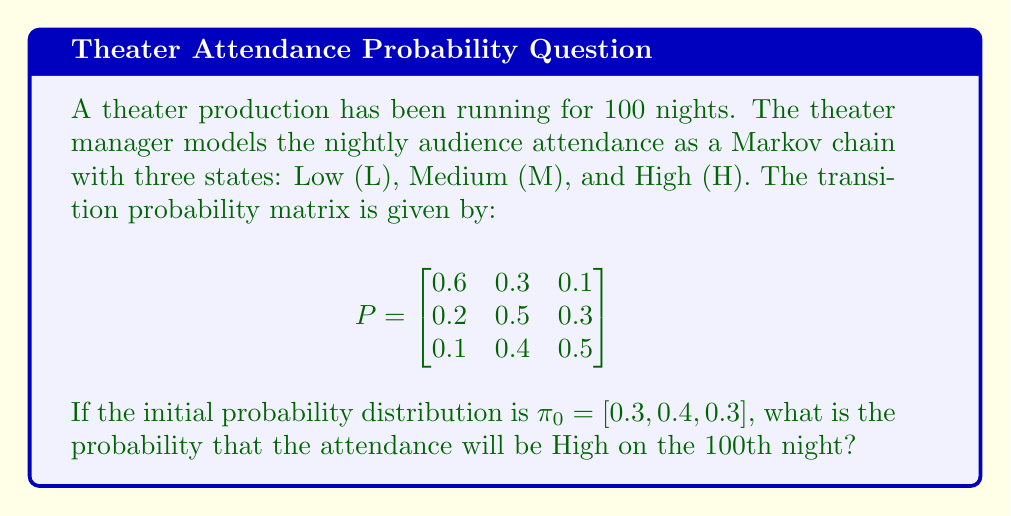Can you answer this question? To solve this problem, we need to find the probability distribution after 100 nights. We can do this by calculating $\pi_{100} = \pi_0 P^{100}$. However, calculating $P^{100}$ directly is computationally intensive. Instead, we can use the fact that for a regular Markov chain, the distribution converges to the stationary distribution as the number of steps increases.

1. First, let's find the stationary distribution $\pi$ by solving the equation $\pi P = \pi$ subject to $\sum_{i} \pi_i = 1$:

   $$\begin{align}
   \pi_1 &= 0.6\pi_1 + 0.2\pi_2 + 0.1\pi_3 \\
   \pi_2 &= 0.3\pi_1 + 0.5\pi_2 + 0.4\pi_3 \\
   \pi_3 &= 0.1\pi_1 + 0.3\pi_2 + 0.5\pi_3 \\
   1 &= \pi_1 + \pi_2 + \pi_3
   \end{align}$$

2. Solving this system of equations (using substitution or matrix methods), we get:
   
   $$\pi = [0.2857, 0.4286, 0.2857]$$

3. Now, we need to check if 100 steps is sufficient for convergence. We can do this by calculating the second largest eigenvalue $\lambda_2$ of $P$:

   $$\lambda_2 \approx 0.3219$$

4. The rate of convergence is governed by $|\lambda_2|^n$, where $n$ is the number of steps. After 100 steps:

   $$|\lambda_2|^{100} \approx (0.3219)^{100} \approx 2.0388 \times 10^{-17}$$

5. This is extremely close to zero, indicating that after 100 steps, the distribution has essentially converged to the stationary distribution.

6. Therefore, we can use the stationary distribution to approximate the probability of High attendance on the 100th night:

   $$P(\text{High on 100th night}) \approx \pi_3 = 0.2857$$
Answer: $0.2857$ 